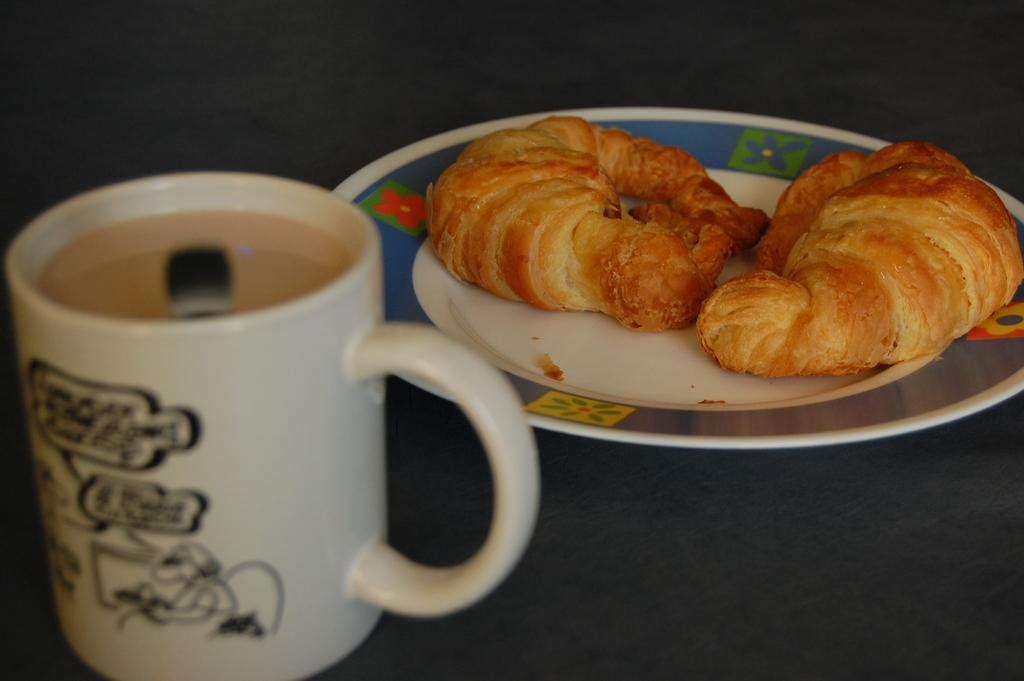What is on the plate in the image? There are food items on the plate in the image. What type of cup is visible in the image? There is a white color cup in the image. Can you describe the background of the image? The background of the image is blurred. What type of rhythm can be heard coming from the toad in the image? There is no toad present in the image, so it's not possible to determine what, if any, rhythm might be heard. 